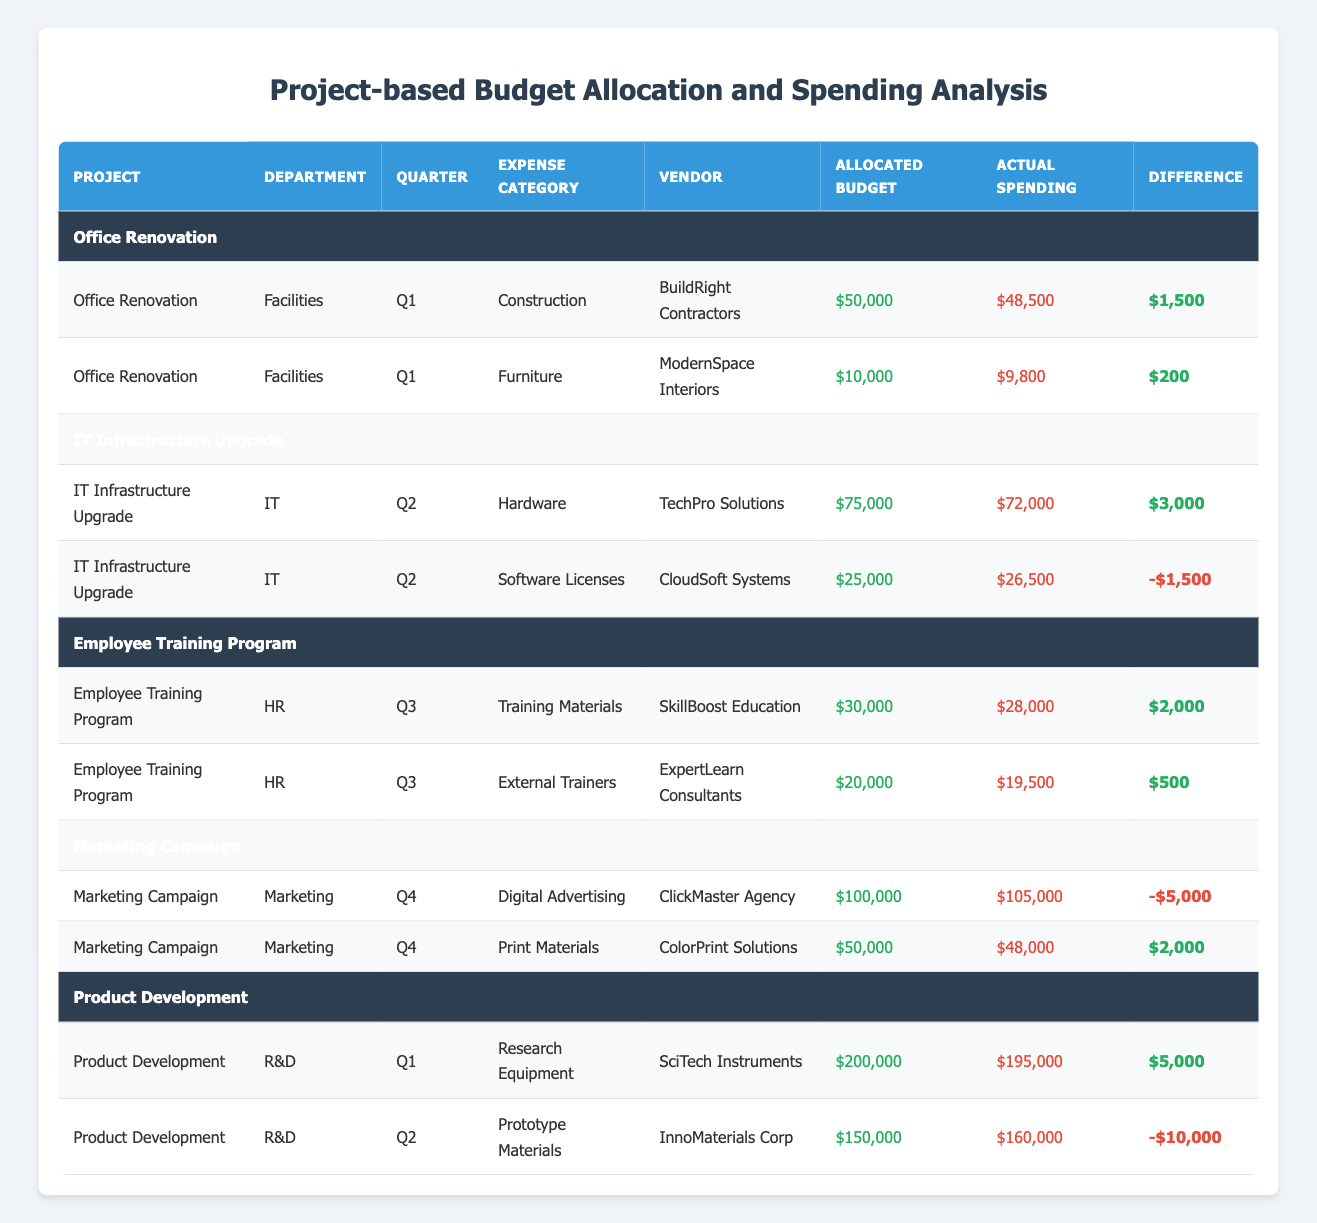What is the total allocated budget for the Office Renovation project? The table shows that the Office Renovation project has an allocated budget of $50,000 for Construction and $10,000 for Furniture. Adding these together gives $50,000 + $10,000 = $60,000.
Answer: $60,000 What was the actual spending for IT Infrastructure Upgrade in Q2? From the table, the actual spending for the IT Infrastructure Upgrade project in Q2 is listed as $72,000 for Hardware and $26,500 for Software Licenses. The total actual spending therefore is $72,000 + $26,500 = $98,500.
Answer: $98,500 Did the Marketing Campaign exceed its allocated budget? The table states that the Marketing Campaign allocated $100,000 for Digital Advertising, but the actual spending was $105,000, which is higher than the allocation. Thus, it did exceed the allocated budget.
Answer: Yes What is the difference between the allocated budget and actual spending for the Employee Training Program? The Employee Training Program has an allocated budget of $30,000 for Training Materials and $20,000 for External Trainers, totaling $50,000. The actual spending is $28,000 + $19,500 = $47,500. The difference is $50,000 - $47,500 = $2,500.
Answer: $2,500 Which project had the highest actual spending in Q1? In Q1, the Project Development had an actual spending of $195,000, which is higher than the Office Renovation's actual spending of $48,500. Thus, Project Development had the highest actual spending in Q1.
Answer: Project Development What is the average allocated budget for projects in the Facilities department? The Facilities department only has the Office Renovation project, which has a total allocated budget of $60,000. As there's only one project, the average is simply the total of $60,000 divided by 1, resulting in $60,000.
Answer: $60,000 Is the spending for Prototype Materials in Project Development above the allocated budget? The Project Development allocated $150,000 for Prototype Materials but spent $160,000. Since the actual spending is greater than the allocation, it is indeed above the allocated budget.
Answer: Yes What is the total actual spending on all projects in Q4? For Q4, the Marketing Campaign spent $105,000 on Digital Advertising and $48,000 on Print Materials. Total actual spending in Q4 is $105,000 + $48,000 = $153,000.
Answer: $153,000 What was the highest spending category for the IT department? The IT department has two spending categories: Hardware with actual spending of $72,000 and Software Licenses with spending of $26,500. Hardware has the highest spending.
Answer: Hardware 